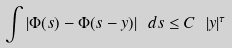Convert formula to latex. <formula><loc_0><loc_0><loc_500><loc_500>\int | \Phi ( s ) - \Phi ( s - y ) | \ d s \leq C \ | y | ^ { \tau }</formula> 